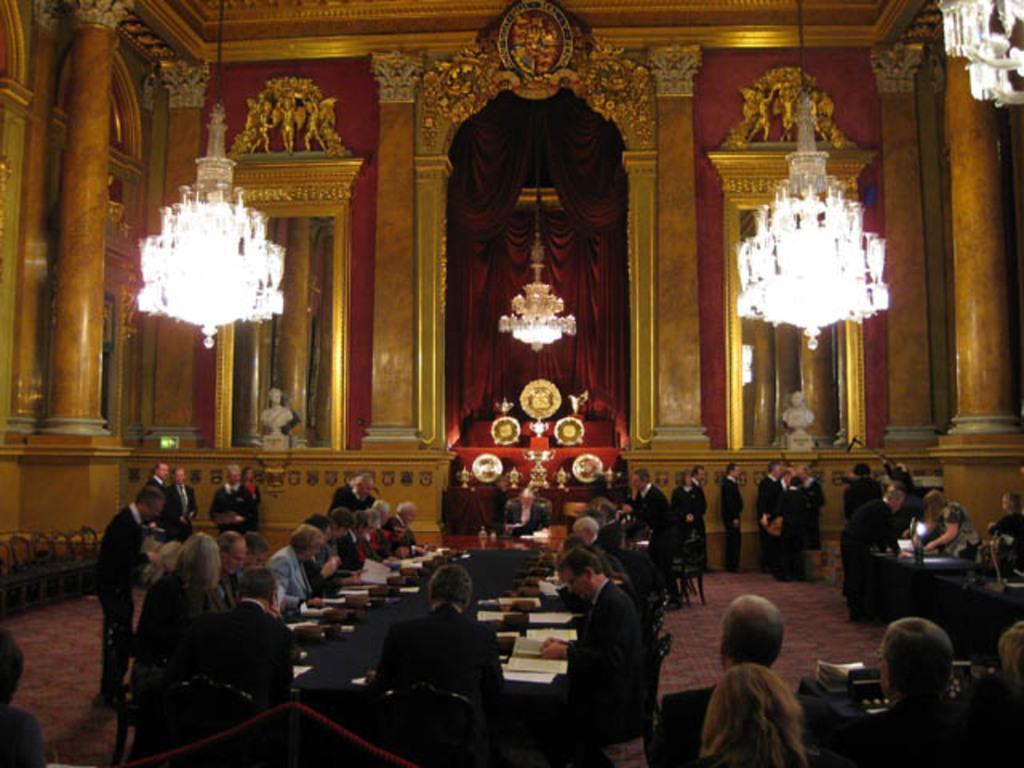Please provide a concise description of this image. In front of the image there is a fence. There are a few people sitting on the chairs and there are a few people standing. In front of them there are tables. On top of it there are papers and some other objects. On the left side of the image there are chairs. In the center of the image there are some objects on the stairs and on the platform. In the background of the image there are pillars, curtains. There are sculptures on the wall. On top of the image there are chandeliers. 